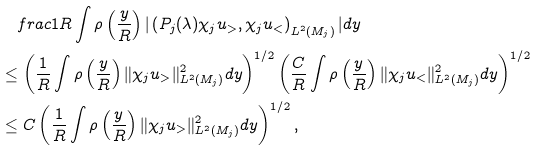Convert formula to latex. <formula><loc_0><loc_0><loc_500><loc_500>& \quad f r a c { 1 } { R } \int \rho \left ( \frac { y } { R } \right ) | \left ( P _ { j } ( \lambda ) \chi _ { j } u _ { > } , \chi _ { j } u _ { < } \right ) _ { L ^ { 2 } ( M _ { j } ) } | d y \\ & \leq \left ( \frac { 1 } { R } \int \rho \left ( \frac { y } { R } \right ) \| \chi _ { j } u _ { > } \| ^ { 2 } _ { L ^ { 2 } ( M _ { j } ) } d y \right ) ^ { 1 / 2 } \left ( \frac { C } { R } \int \rho \left ( \frac { y } { R } \right ) \| \chi _ { j } u _ { < } \| ^ { 2 } _ { L ^ { 2 } ( M _ { j } ) } d y \right ) ^ { 1 / 2 } \\ & \leq C \left ( \frac { 1 } { R } \int \rho \left ( \frac { y } { R } \right ) \| \chi _ { j } u _ { > } \| ^ { 2 } _ { L ^ { 2 } ( M _ { j } ) } d y \right ) ^ { 1 / 2 } ,</formula> 